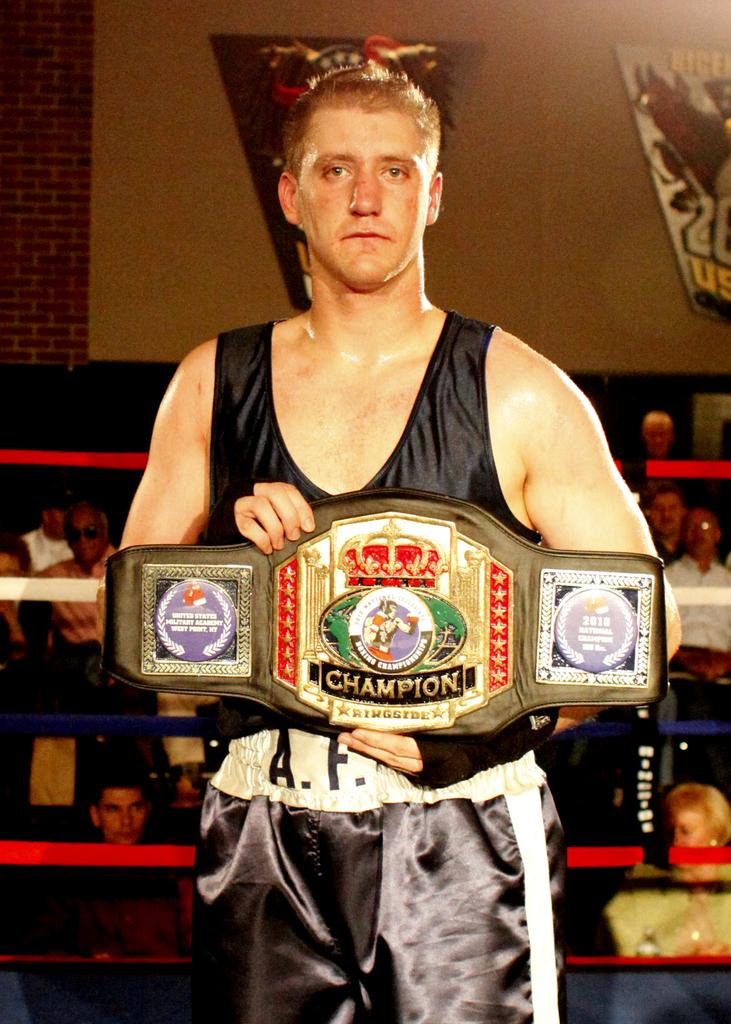<image>
Describe the image concisely. An athlete holds up a gold and black champion belt in the ring. 